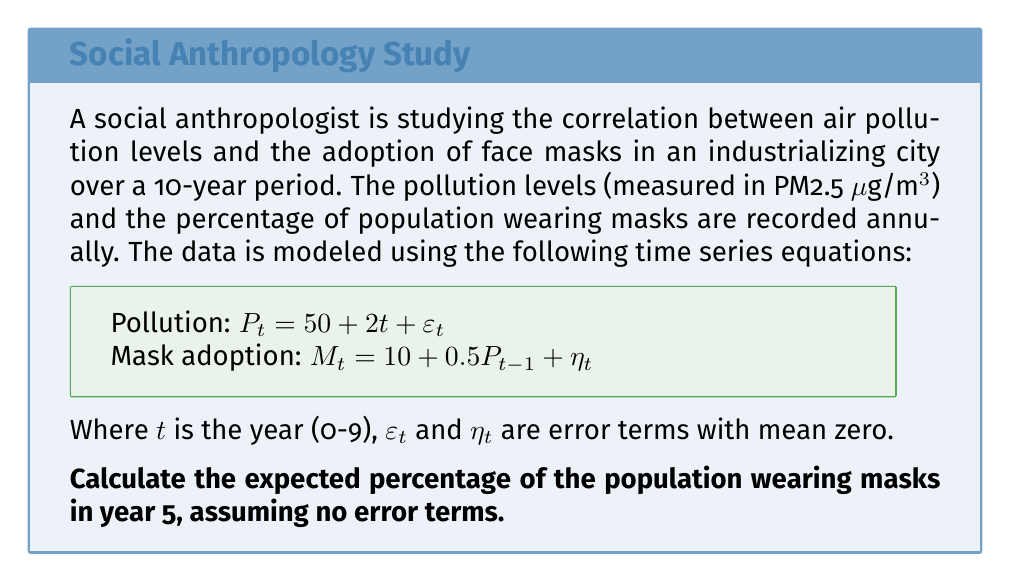Could you help me with this problem? To solve this problem, we need to follow these steps:

1. Calculate the pollution level for year 4 (since mask adoption depends on the previous year's pollution):
   $P_4 = 50 + 2(4) = 58$ μg/m³

2. Use this pollution level to calculate the mask adoption for year 5:
   $M_5 = 10 + 0.5P_4$

3. Substitute the value of $P_4$ into the mask adoption equation:
   $M_5 = 10 + 0.5(58)$

4. Solve the equation:
   $M_5 = 10 + 29 = 39$

Therefore, in year 5, we expect 39% of the population to be wearing masks, assuming no error terms.

This analysis demonstrates how societal adaptations (mask-wearing) lag behind environmental changes (pollution levels), which is a key concept in studying the cultural impact of industrialization.
Answer: 39% 